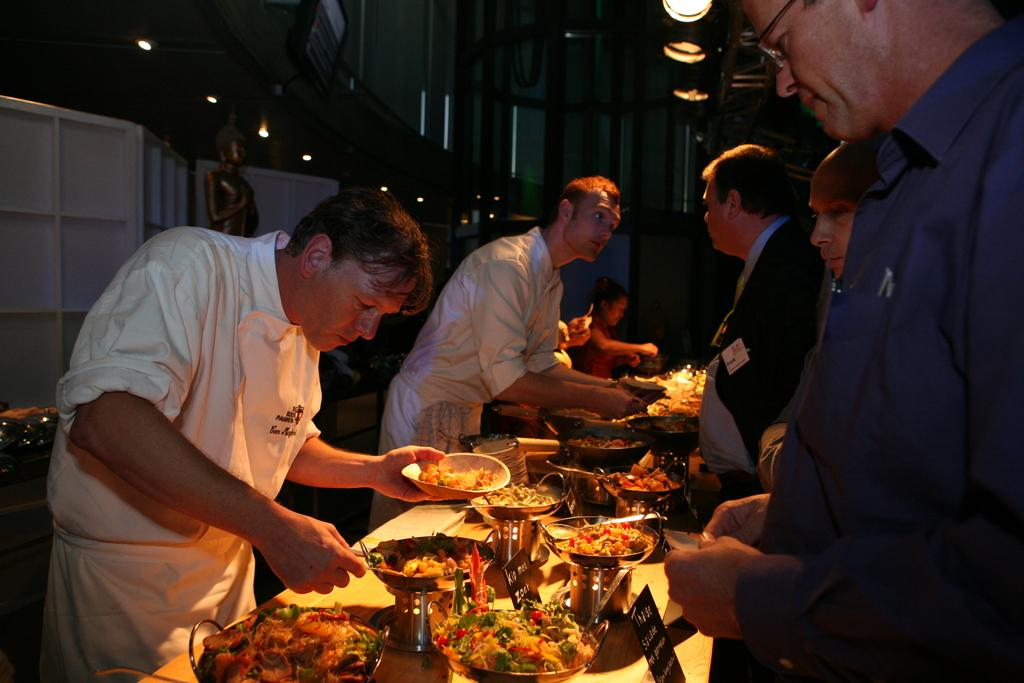Who or what is present in the image? There are people in the image. What can be seen in the background of the image? There is a wall in the image. What type of illumination is visible in the image? There are lights in the image. What type of furniture is present in the image? There are tables in the image. What is on top of the tables in the image? There are bowls on the tables. What is inside the bowls on the tables? There are food items on the tables. What type of brass instrument is being played in the image? There is no brass instrument present in the image. 